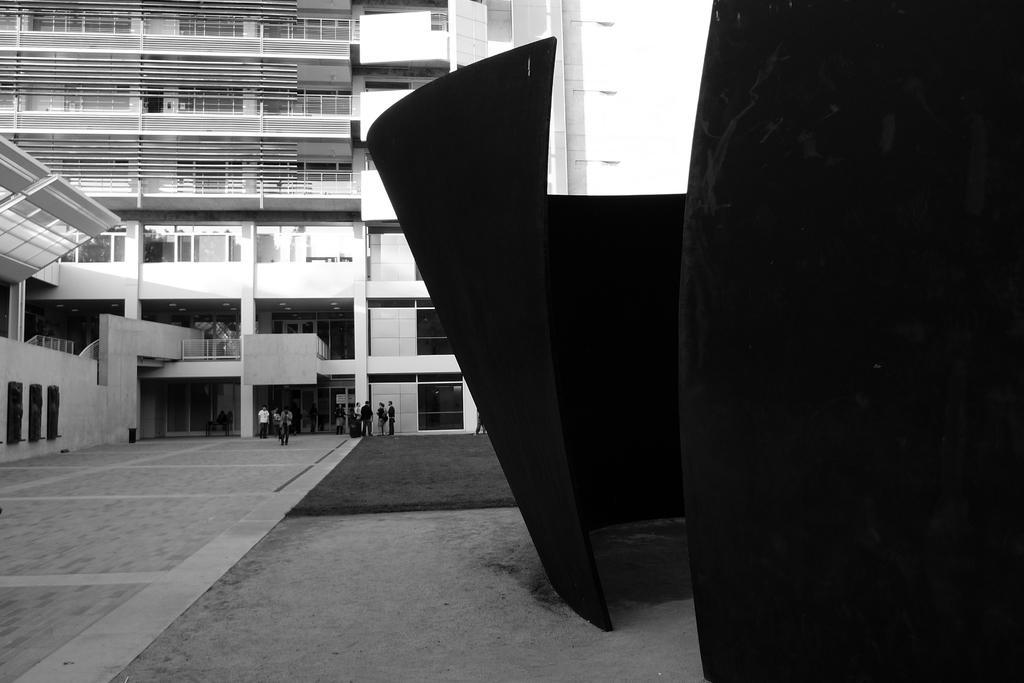Could you give a brief overview of what you see in this image? In the center of the image there is a building. On the right there is a wall. At the bottom we can see people standing and there is a mat. 